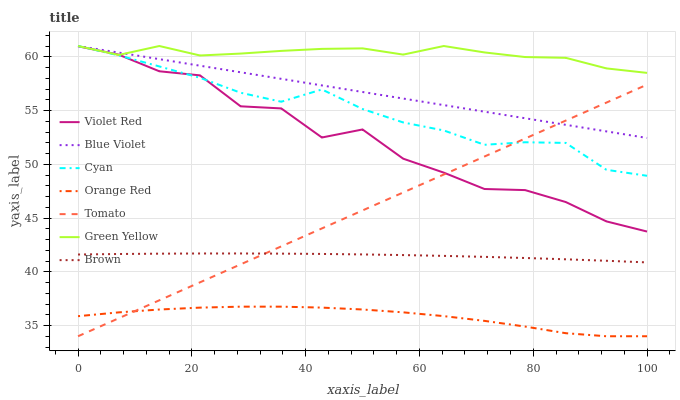Does Orange Red have the minimum area under the curve?
Answer yes or no. Yes. Does Green Yellow have the maximum area under the curve?
Answer yes or no. Yes. Does Brown have the minimum area under the curve?
Answer yes or no. No. Does Brown have the maximum area under the curve?
Answer yes or no. No. Is Tomato the smoothest?
Answer yes or no. Yes. Is Violet Red the roughest?
Answer yes or no. Yes. Is Brown the smoothest?
Answer yes or no. No. Is Brown the roughest?
Answer yes or no. No. Does Tomato have the lowest value?
Answer yes or no. Yes. Does Brown have the lowest value?
Answer yes or no. No. Does Blue Violet have the highest value?
Answer yes or no. Yes. Does Brown have the highest value?
Answer yes or no. No. Is Orange Red less than Brown?
Answer yes or no. Yes. Is Brown greater than Orange Red?
Answer yes or no. Yes. Does Blue Violet intersect Green Yellow?
Answer yes or no. Yes. Is Blue Violet less than Green Yellow?
Answer yes or no. No. Is Blue Violet greater than Green Yellow?
Answer yes or no. No. Does Orange Red intersect Brown?
Answer yes or no. No. 